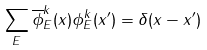Convert formula to latex. <formula><loc_0><loc_0><loc_500><loc_500>\sum _ { E } \overline { \phi } _ { E } ^ { k } ( x ) \phi _ { E } ^ { k } ( x ^ { \prime } ) = \delta ( x - x ^ { \prime } )</formula> 